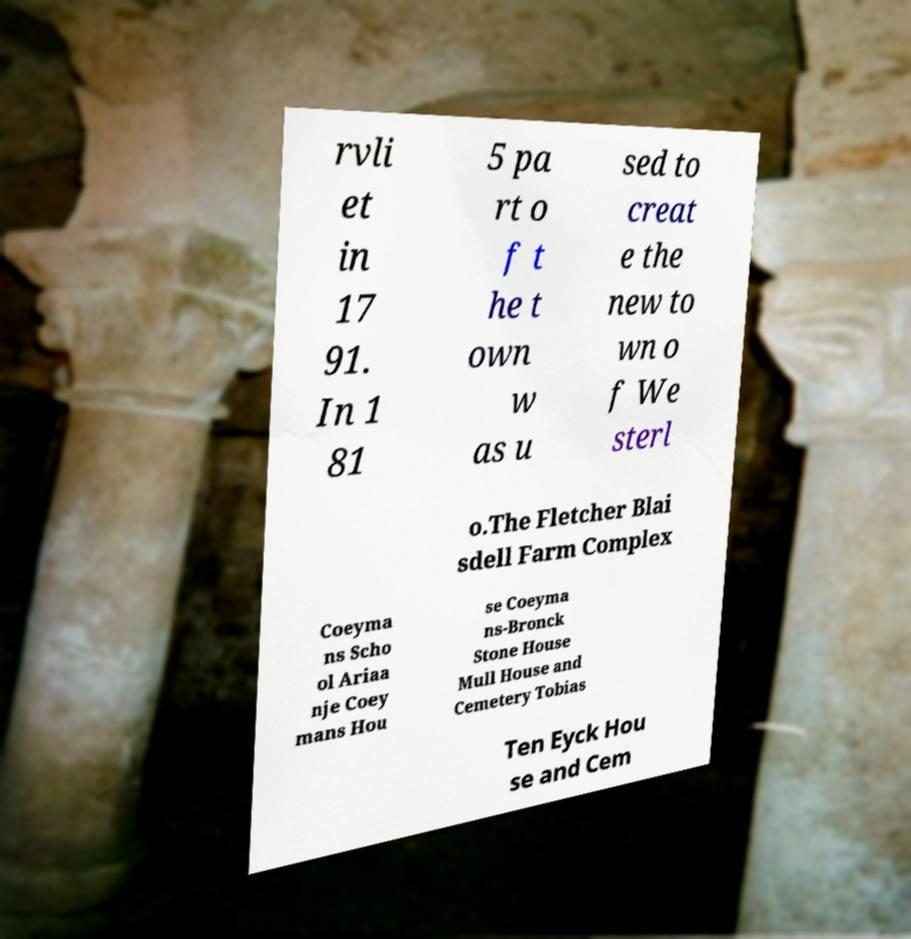Could you extract and type out the text from this image? rvli et in 17 91. In 1 81 5 pa rt o f t he t own w as u sed to creat e the new to wn o f We sterl o.The Fletcher Blai sdell Farm Complex Coeyma ns Scho ol Ariaa nje Coey mans Hou se Coeyma ns-Bronck Stone House Mull House and Cemetery Tobias Ten Eyck Hou se and Cem 